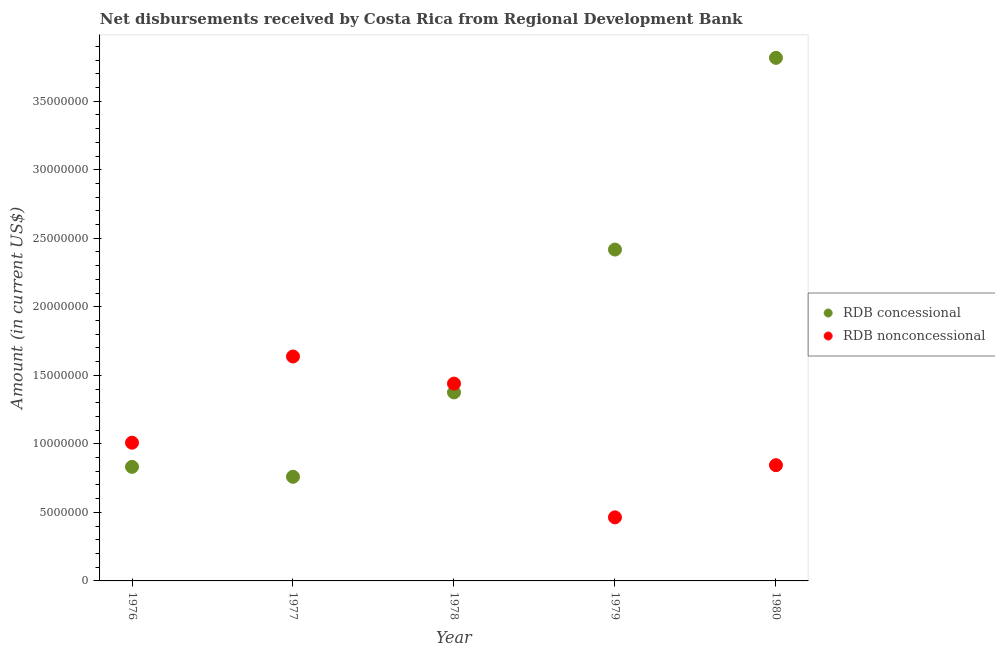Is the number of dotlines equal to the number of legend labels?
Offer a terse response. Yes. What is the net concessional disbursements from rdb in 1977?
Give a very brief answer. 7.60e+06. Across all years, what is the maximum net concessional disbursements from rdb?
Provide a short and direct response. 3.82e+07. Across all years, what is the minimum net non concessional disbursements from rdb?
Offer a very short reply. 4.64e+06. In which year was the net concessional disbursements from rdb maximum?
Provide a short and direct response. 1980. In which year was the net non concessional disbursements from rdb minimum?
Your response must be concise. 1979. What is the total net non concessional disbursements from rdb in the graph?
Offer a terse response. 5.39e+07. What is the difference between the net non concessional disbursements from rdb in 1977 and that in 1980?
Your response must be concise. 7.93e+06. What is the difference between the net non concessional disbursements from rdb in 1978 and the net concessional disbursements from rdb in 1980?
Provide a succinct answer. -2.38e+07. What is the average net concessional disbursements from rdb per year?
Ensure brevity in your answer.  1.84e+07. In the year 1976, what is the difference between the net non concessional disbursements from rdb and net concessional disbursements from rdb?
Give a very brief answer. 1.76e+06. In how many years, is the net non concessional disbursements from rdb greater than 36000000 US$?
Your response must be concise. 0. What is the ratio of the net non concessional disbursements from rdb in 1978 to that in 1979?
Offer a very short reply. 3.1. Is the net concessional disbursements from rdb in 1976 less than that in 1977?
Make the answer very short. No. What is the difference between the highest and the second highest net concessional disbursements from rdb?
Provide a succinct answer. 1.40e+07. What is the difference between the highest and the lowest net non concessional disbursements from rdb?
Offer a terse response. 1.17e+07. Is the net non concessional disbursements from rdb strictly greater than the net concessional disbursements from rdb over the years?
Your answer should be very brief. No. Is the net non concessional disbursements from rdb strictly less than the net concessional disbursements from rdb over the years?
Provide a succinct answer. No. How many dotlines are there?
Your answer should be very brief. 2. How many years are there in the graph?
Keep it short and to the point. 5. Are the values on the major ticks of Y-axis written in scientific E-notation?
Give a very brief answer. No. Does the graph contain any zero values?
Make the answer very short. No. Does the graph contain grids?
Make the answer very short. No. How many legend labels are there?
Give a very brief answer. 2. How are the legend labels stacked?
Your response must be concise. Vertical. What is the title of the graph?
Keep it short and to the point. Net disbursements received by Costa Rica from Regional Development Bank. Does "Personal remittances" appear as one of the legend labels in the graph?
Provide a short and direct response. No. What is the label or title of the X-axis?
Provide a succinct answer. Year. What is the label or title of the Y-axis?
Ensure brevity in your answer.  Amount (in current US$). What is the Amount (in current US$) of RDB concessional in 1976?
Make the answer very short. 8.32e+06. What is the Amount (in current US$) in RDB nonconcessional in 1976?
Keep it short and to the point. 1.01e+07. What is the Amount (in current US$) in RDB concessional in 1977?
Provide a short and direct response. 7.60e+06. What is the Amount (in current US$) in RDB nonconcessional in 1977?
Give a very brief answer. 1.64e+07. What is the Amount (in current US$) in RDB concessional in 1978?
Provide a succinct answer. 1.38e+07. What is the Amount (in current US$) of RDB nonconcessional in 1978?
Your response must be concise. 1.44e+07. What is the Amount (in current US$) in RDB concessional in 1979?
Provide a succinct answer. 2.42e+07. What is the Amount (in current US$) of RDB nonconcessional in 1979?
Provide a succinct answer. 4.64e+06. What is the Amount (in current US$) of RDB concessional in 1980?
Ensure brevity in your answer.  3.82e+07. What is the Amount (in current US$) of RDB nonconcessional in 1980?
Provide a short and direct response. 8.44e+06. Across all years, what is the maximum Amount (in current US$) in RDB concessional?
Keep it short and to the point. 3.82e+07. Across all years, what is the maximum Amount (in current US$) of RDB nonconcessional?
Offer a terse response. 1.64e+07. Across all years, what is the minimum Amount (in current US$) in RDB concessional?
Provide a short and direct response. 7.60e+06. Across all years, what is the minimum Amount (in current US$) in RDB nonconcessional?
Give a very brief answer. 4.64e+06. What is the total Amount (in current US$) in RDB concessional in the graph?
Your answer should be compact. 9.20e+07. What is the total Amount (in current US$) in RDB nonconcessional in the graph?
Provide a succinct answer. 5.39e+07. What is the difference between the Amount (in current US$) in RDB concessional in 1976 and that in 1977?
Your answer should be very brief. 7.26e+05. What is the difference between the Amount (in current US$) of RDB nonconcessional in 1976 and that in 1977?
Give a very brief answer. -6.29e+06. What is the difference between the Amount (in current US$) in RDB concessional in 1976 and that in 1978?
Your answer should be compact. -5.43e+06. What is the difference between the Amount (in current US$) in RDB nonconcessional in 1976 and that in 1978?
Give a very brief answer. -4.31e+06. What is the difference between the Amount (in current US$) in RDB concessional in 1976 and that in 1979?
Offer a very short reply. -1.59e+07. What is the difference between the Amount (in current US$) in RDB nonconcessional in 1976 and that in 1979?
Your response must be concise. 5.45e+06. What is the difference between the Amount (in current US$) of RDB concessional in 1976 and that in 1980?
Your answer should be very brief. -2.98e+07. What is the difference between the Amount (in current US$) in RDB nonconcessional in 1976 and that in 1980?
Your answer should be very brief. 1.64e+06. What is the difference between the Amount (in current US$) of RDB concessional in 1977 and that in 1978?
Offer a terse response. -6.16e+06. What is the difference between the Amount (in current US$) in RDB nonconcessional in 1977 and that in 1978?
Your answer should be compact. 1.98e+06. What is the difference between the Amount (in current US$) of RDB concessional in 1977 and that in 1979?
Provide a succinct answer. -1.66e+07. What is the difference between the Amount (in current US$) of RDB nonconcessional in 1977 and that in 1979?
Keep it short and to the point. 1.17e+07. What is the difference between the Amount (in current US$) of RDB concessional in 1977 and that in 1980?
Keep it short and to the point. -3.06e+07. What is the difference between the Amount (in current US$) in RDB nonconcessional in 1977 and that in 1980?
Give a very brief answer. 7.93e+06. What is the difference between the Amount (in current US$) of RDB concessional in 1978 and that in 1979?
Your answer should be very brief. -1.04e+07. What is the difference between the Amount (in current US$) of RDB nonconcessional in 1978 and that in 1979?
Your response must be concise. 9.76e+06. What is the difference between the Amount (in current US$) of RDB concessional in 1978 and that in 1980?
Provide a short and direct response. -2.44e+07. What is the difference between the Amount (in current US$) of RDB nonconcessional in 1978 and that in 1980?
Give a very brief answer. 5.95e+06. What is the difference between the Amount (in current US$) in RDB concessional in 1979 and that in 1980?
Provide a short and direct response. -1.40e+07. What is the difference between the Amount (in current US$) of RDB nonconcessional in 1979 and that in 1980?
Your response must be concise. -3.80e+06. What is the difference between the Amount (in current US$) of RDB concessional in 1976 and the Amount (in current US$) of RDB nonconcessional in 1977?
Keep it short and to the point. -8.05e+06. What is the difference between the Amount (in current US$) in RDB concessional in 1976 and the Amount (in current US$) in RDB nonconcessional in 1978?
Offer a very short reply. -6.07e+06. What is the difference between the Amount (in current US$) of RDB concessional in 1976 and the Amount (in current US$) of RDB nonconcessional in 1979?
Provide a succinct answer. 3.68e+06. What is the difference between the Amount (in current US$) in RDB concessional in 1976 and the Amount (in current US$) in RDB nonconcessional in 1980?
Give a very brief answer. -1.21e+05. What is the difference between the Amount (in current US$) of RDB concessional in 1977 and the Amount (in current US$) of RDB nonconcessional in 1978?
Provide a short and direct response. -6.80e+06. What is the difference between the Amount (in current US$) of RDB concessional in 1977 and the Amount (in current US$) of RDB nonconcessional in 1979?
Offer a very short reply. 2.96e+06. What is the difference between the Amount (in current US$) of RDB concessional in 1977 and the Amount (in current US$) of RDB nonconcessional in 1980?
Provide a succinct answer. -8.47e+05. What is the difference between the Amount (in current US$) in RDB concessional in 1978 and the Amount (in current US$) in RDB nonconcessional in 1979?
Ensure brevity in your answer.  9.11e+06. What is the difference between the Amount (in current US$) of RDB concessional in 1978 and the Amount (in current US$) of RDB nonconcessional in 1980?
Make the answer very short. 5.31e+06. What is the difference between the Amount (in current US$) of RDB concessional in 1979 and the Amount (in current US$) of RDB nonconcessional in 1980?
Provide a short and direct response. 1.57e+07. What is the average Amount (in current US$) in RDB concessional per year?
Provide a short and direct response. 1.84e+07. What is the average Amount (in current US$) of RDB nonconcessional per year?
Give a very brief answer. 1.08e+07. In the year 1976, what is the difference between the Amount (in current US$) in RDB concessional and Amount (in current US$) in RDB nonconcessional?
Ensure brevity in your answer.  -1.76e+06. In the year 1977, what is the difference between the Amount (in current US$) of RDB concessional and Amount (in current US$) of RDB nonconcessional?
Your answer should be very brief. -8.78e+06. In the year 1978, what is the difference between the Amount (in current US$) in RDB concessional and Amount (in current US$) in RDB nonconcessional?
Your response must be concise. -6.44e+05. In the year 1979, what is the difference between the Amount (in current US$) of RDB concessional and Amount (in current US$) of RDB nonconcessional?
Your response must be concise. 1.95e+07. In the year 1980, what is the difference between the Amount (in current US$) in RDB concessional and Amount (in current US$) in RDB nonconcessional?
Offer a terse response. 2.97e+07. What is the ratio of the Amount (in current US$) of RDB concessional in 1976 to that in 1977?
Offer a terse response. 1.1. What is the ratio of the Amount (in current US$) in RDB nonconcessional in 1976 to that in 1977?
Provide a short and direct response. 0.62. What is the ratio of the Amount (in current US$) of RDB concessional in 1976 to that in 1978?
Your response must be concise. 0.61. What is the ratio of the Amount (in current US$) in RDB nonconcessional in 1976 to that in 1978?
Offer a terse response. 0.7. What is the ratio of the Amount (in current US$) in RDB concessional in 1976 to that in 1979?
Provide a succinct answer. 0.34. What is the ratio of the Amount (in current US$) of RDB nonconcessional in 1976 to that in 1979?
Make the answer very short. 2.17. What is the ratio of the Amount (in current US$) in RDB concessional in 1976 to that in 1980?
Ensure brevity in your answer.  0.22. What is the ratio of the Amount (in current US$) of RDB nonconcessional in 1976 to that in 1980?
Provide a short and direct response. 1.19. What is the ratio of the Amount (in current US$) in RDB concessional in 1977 to that in 1978?
Your answer should be very brief. 0.55. What is the ratio of the Amount (in current US$) of RDB nonconcessional in 1977 to that in 1978?
Offer a terse response. 1.14. What is the ratio of the Amount (in current US$) of RDB concessional in 1977 to that in 1979?
Provide a short and direct response. 0.31. What is the ratio of the Amount (in current US$) of RDB nonconcessional in 1977 to that in 1979?
Keep it short and to the point. 3.53. What is the ratio of the Amount (in current US$) in RDB concessional in 1977 to that in 1980?
Offer a terse response. 0.2. What is the ratio of the Amount (in current US$) in RDB nonconcessional in 1977 to that in 1980?
Your response must be concise. 1.94. What is the ratio of the Amount (in current US$) of RDB concessional in 1978 to that in 1979?
Offer a terse response. 0.57. What is the ratio of the Amount (in current US$) of RDB nonconcessional in 1978 to that in 1979?
Ensure brevity in your answer.  3.1. What is the ratio of the Amount (in current US$) of RDB concessional in 1978 to that in 1980?
Offer a terse response. 0.36. What is the ratio of the Amount (in current US$) of RDB nonconcessional in 1978 to that in 1980?
Your response must be concise. 1.71. What is the ratio of the Amount (in current US$) in RDB concessional in 1979 to that in 1980?
Keep it short and to the point. 0.63. What is the ratio of the Amount (in current US$) of RDB nonconcessional in 1979 to that in 1980?
Make the answer very short. 0.55. What is the difference between the highest and the second highest Amount (in current US$) in RDB concessional?
Provide a short and direct response. 1.40e+07. What is the difference between the highest and the second highest Amount (in current US$) in RDB nonconcessional?
Your answer should be compact. 1.98e+06. What is the difference between the highest and the lowest Amount (in current US$) in RDB concessional?
Offer a very short reply. 3.06e+07. What is the difference between the highest and the lowest Amount (in current US$) in RDB nonconcessional?
Make the answer very short. 1.17e+07. 